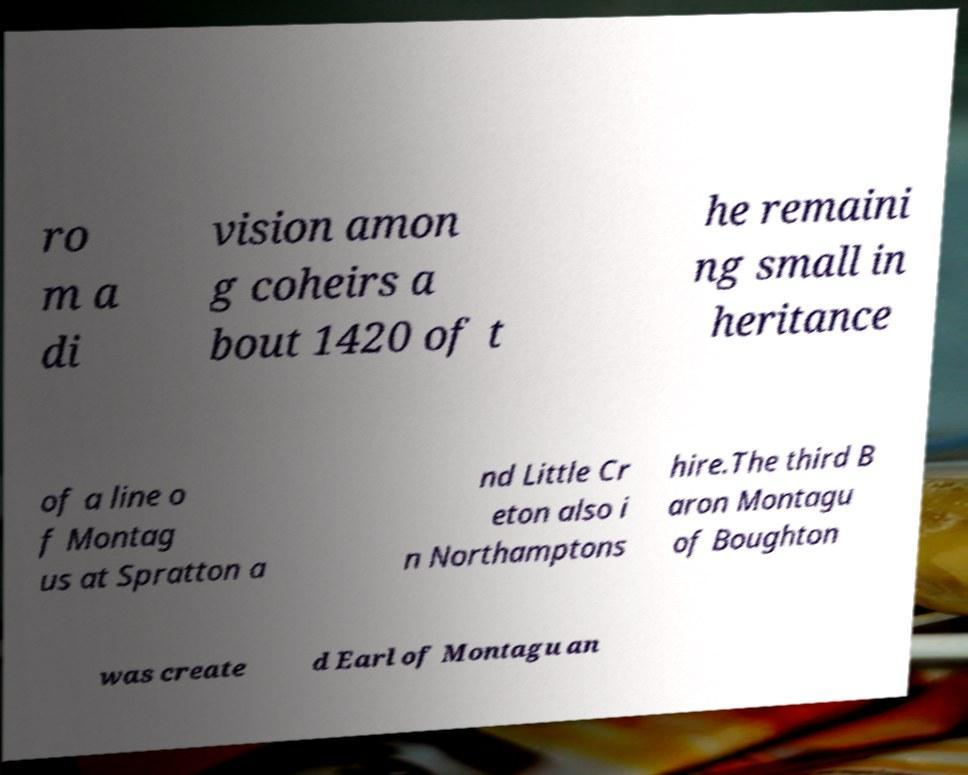Can you accurately transcribe the text from the provided image for me? ro m a di vision amon g coheirs a bout 1420 of t he remaini ng small in heritance of a line o f Montag us at Spratton a nd Little Cr eton also i n Northamptons hire.The third B aron Montagu of Boughton was create d Earl of Montagu an 